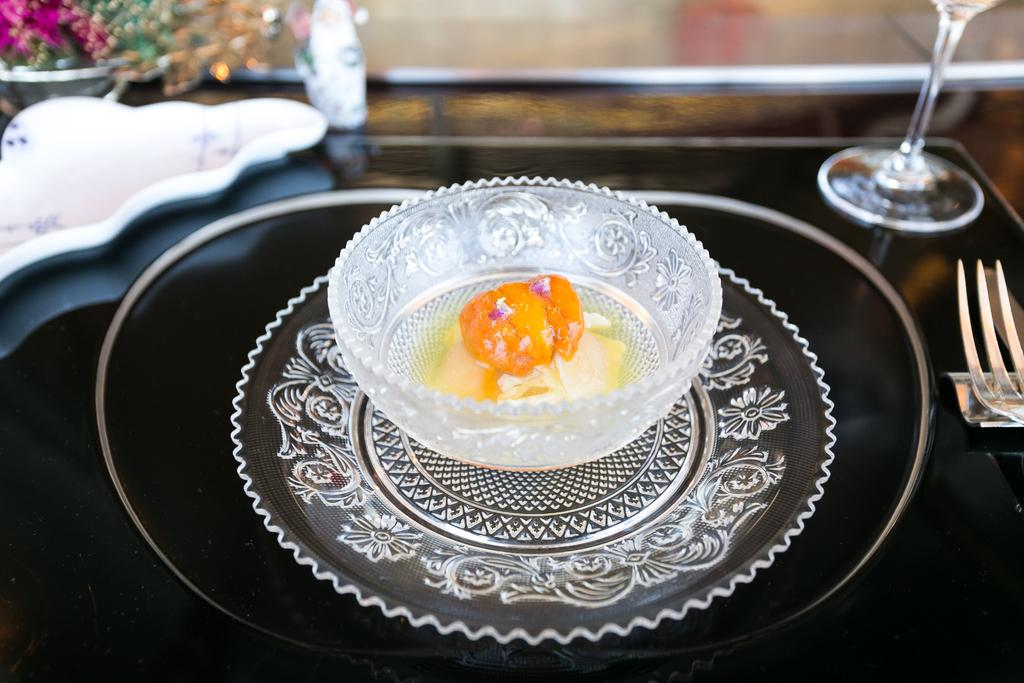What piece of furniture is present in the image? There is a table in the image. What object is placed on the table? There is a glass on the table. What utensil can be seen on the table? There is a fork on the table. What is contained in the bowl on the table? There is a bowl with a food item on the table. Is there a slope visible in the image? There is no slope present in the image; it features a table with various objects on it. 